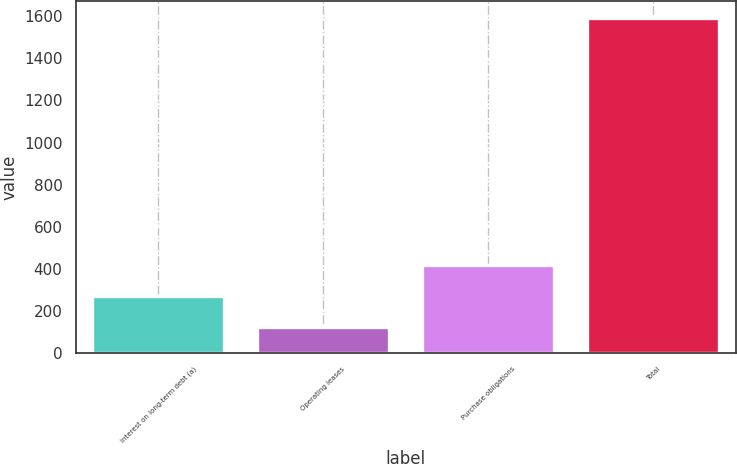Convert chart. <chart><loc_0><loc_0><loc_500><loc_500><bar_chart><fcel>Interest on long-term debt (a)<fcel>Operating leases<fcel>Purchase obligations<fcel>Total<nl><fcel>268.1<fcel>121<fcel>415.2<fcel>1592<nl></chart> 